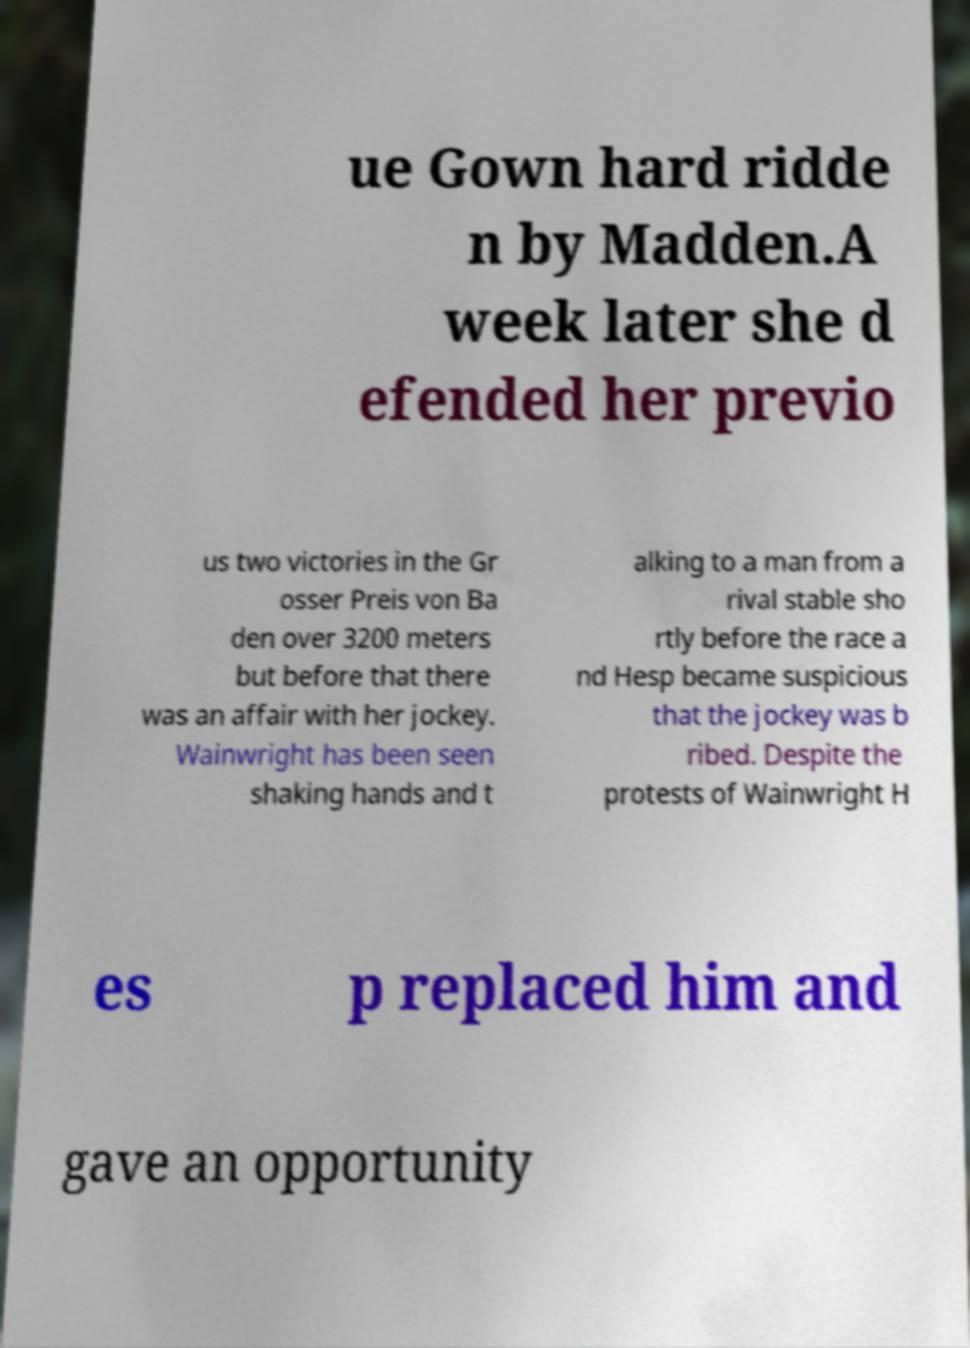There's text embedded in this image that I need extracted. Can you transcribe it verbatim? ue Gown hard ridde n by Madden.A week later she d efended her previo us two victories in the Gr osser Preis von Ba den over 3200 meters but before that there was an affair with her jockey. Wainwright has been seen shaking hands and t alking to a man from a rival stable sho rtly before the race a nd Hesp became suspicious that the jockey was b ribed. Despite the protests of Wainwright H es p replaced him and gave an opportunity 